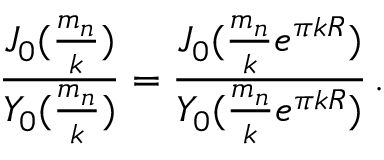<formula> <loc_0><loc_0><loc_500><loc_500>\frac { J _ { 0 } ( \frac { m _ { n } } { k } ) } { Y _ { 0 } ( \frac { m _ { n } } { k } ) } = \frac { J _ { 0 } ( \frac { m _ { n } } { k } e ^ { \pi k R } ) } { Y _ { 0 } ( \frac { m _ { n } } { k } e ^ { \pi k R } ) } \, .</formula> 